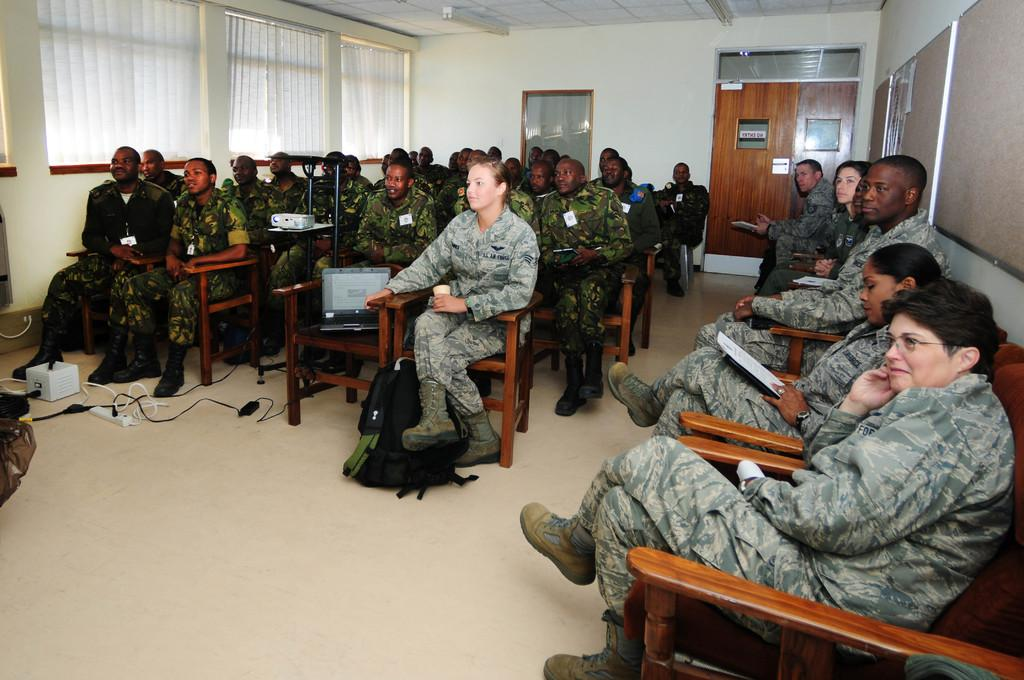What is the main subject of the image? The main subject of the image is a group of people. What are the people in the image doing? The people are sitting on chairs. What can be seen on the right side of the image? There is a door on the right side of the image. What type of sign can be seen in the image? There is no sign present in the image. How many people are coughing in the image? There is no indication of anyone coughing in the image. 